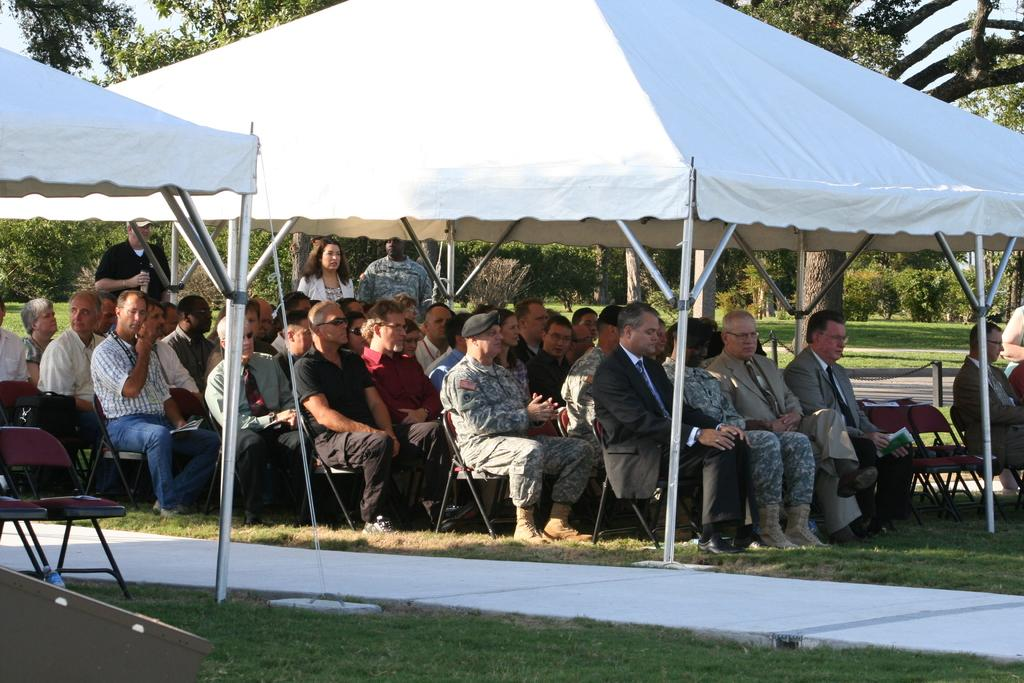What are the people in the image doing? There are people sitting on chairs and standing in the image. What type of structure is present in the image? There is a tent in the image. What is the ground surface like in the image? There is grass in the image. What can be seen in the background of the image? Trees and the sky are visible in the background. What type of seating is available in the image? There are chairs in the image. Can you see any sea creatures in the image? There is no sea or sea creatures present in the image; it features people, a tent, grass, trees, and chairs. What type of pin is being used to hold the tent in place in the image? There is no pin mentioned or visible in the image; the tent's stability is not discussed. 